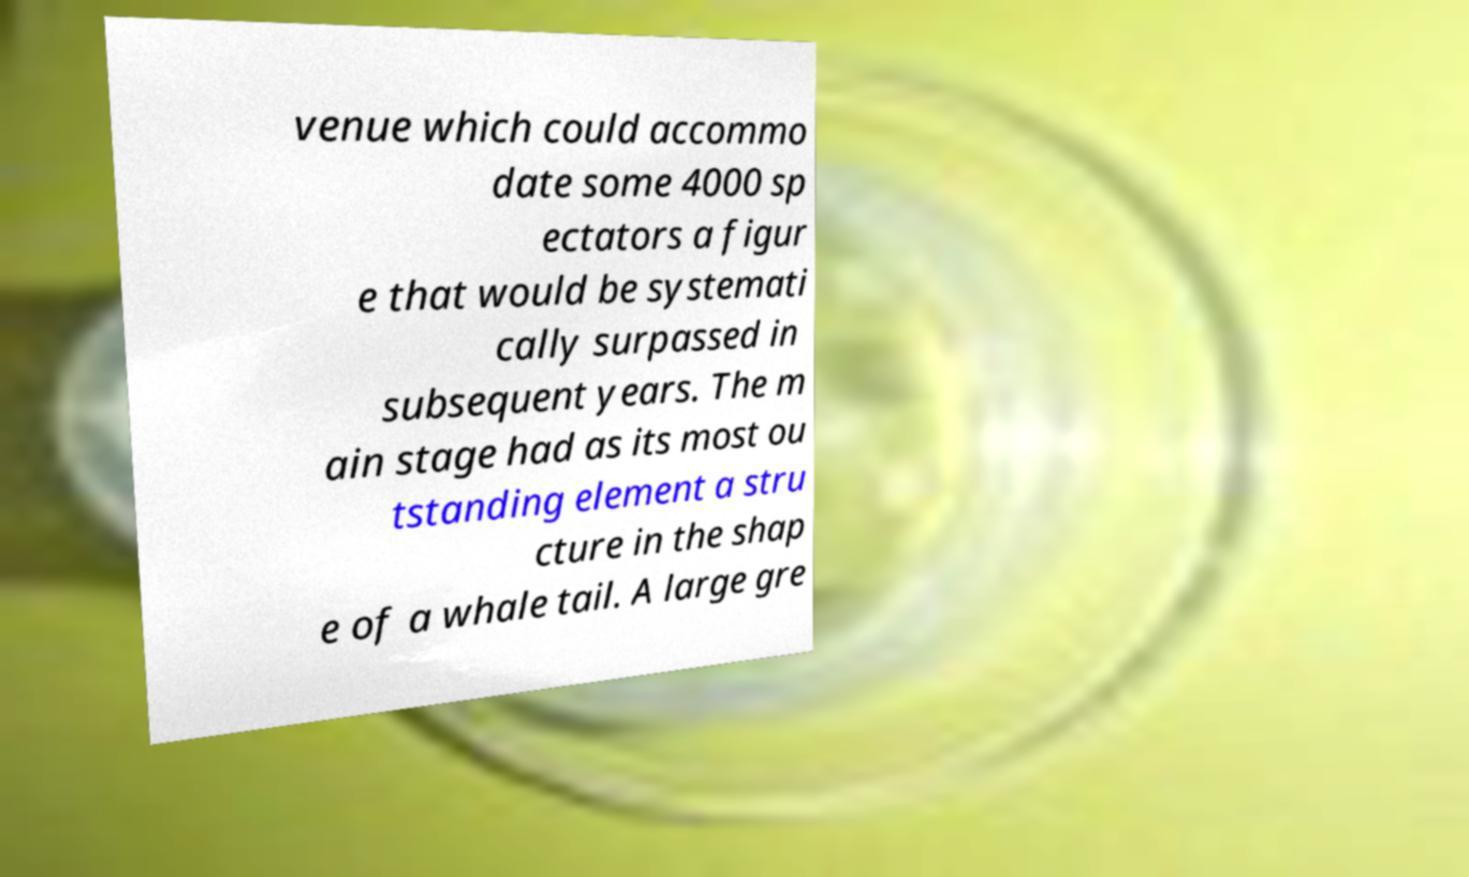Please identify and transcribe the text found in this image. venue which could accommo date some 4000 sp ectators a figur e that would be systemati cally surpassed in subsequent years. The m ain stage had as its most ou tstanding element a stru cture in the shap e of a whale tail. A large gre 